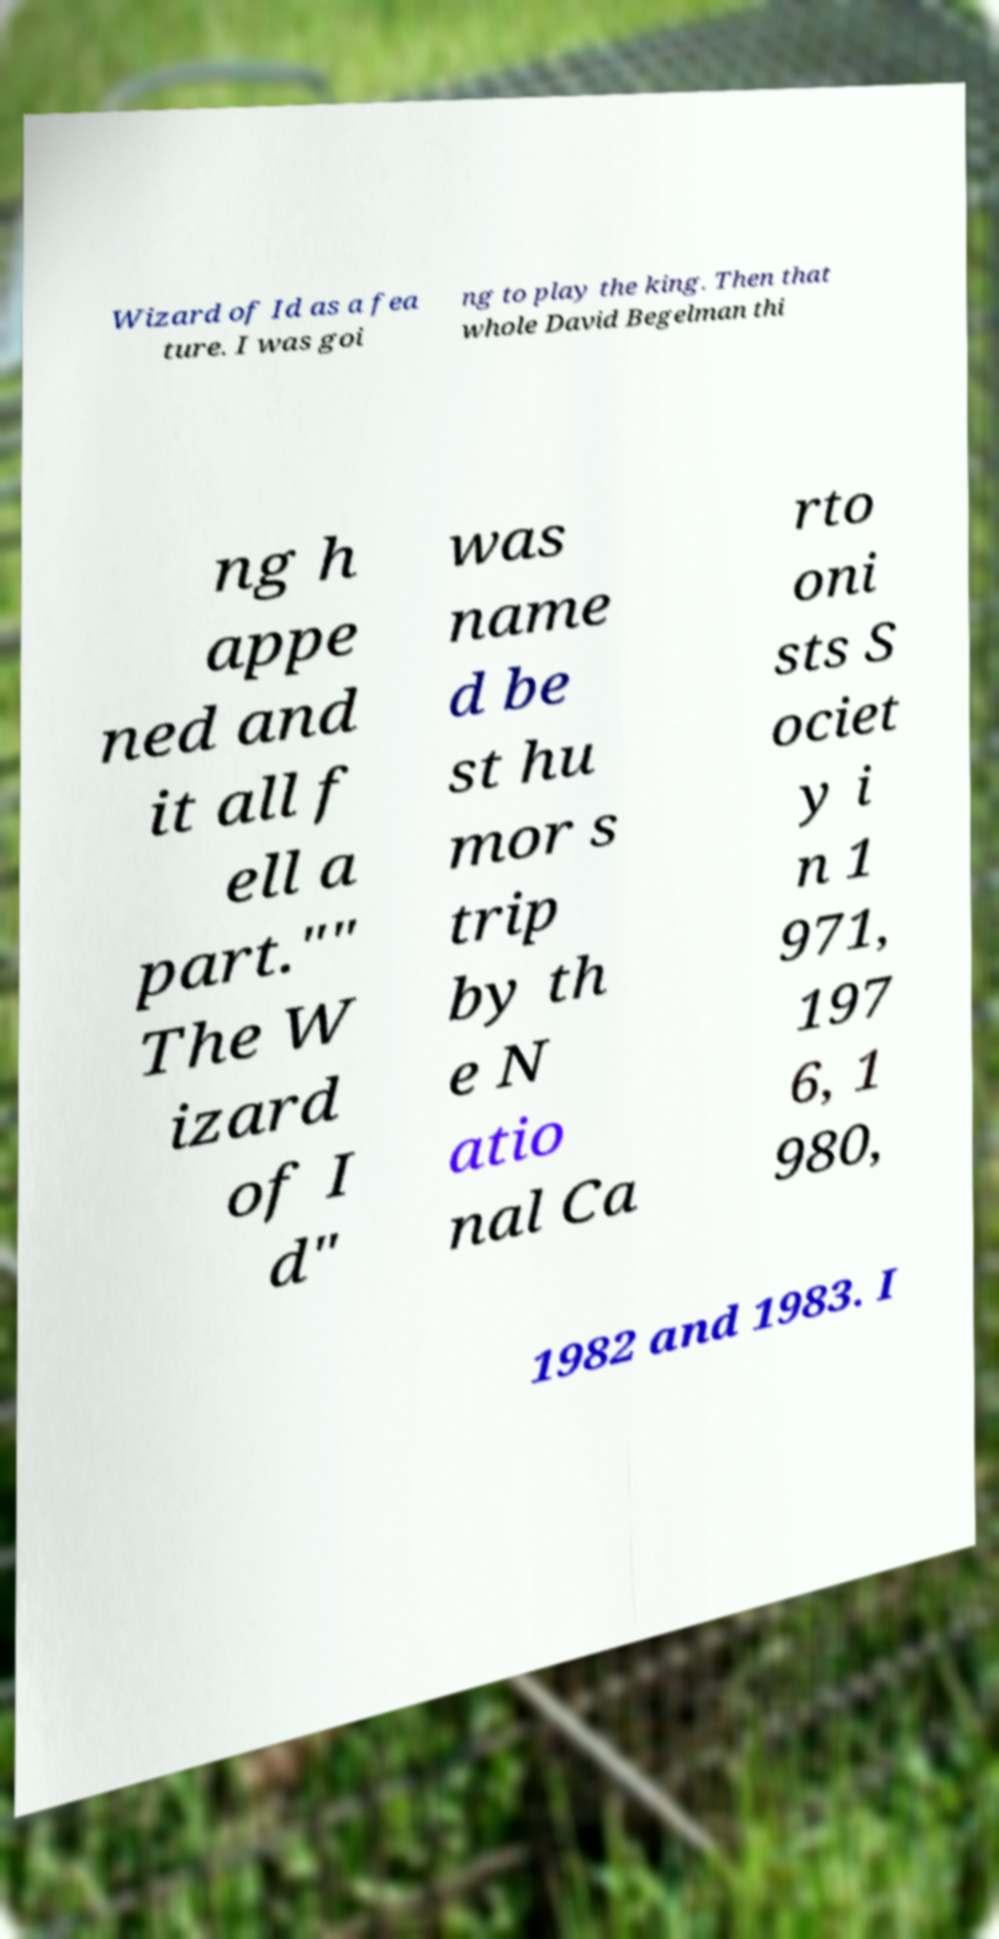I need the written content from this picture converted into text. Can you do that? Wizard of Id as a fea ture. I was goi ng to play the king. Then that whole David Begelman thi ng h appe ned and it all f ell a part."" The W izard of I d" was name d be st hu mor s trip by th e N atio nal Ca rto oni sts S ociet y i n 1 971, 197 6, 1 980, 1982 and 1983. I 